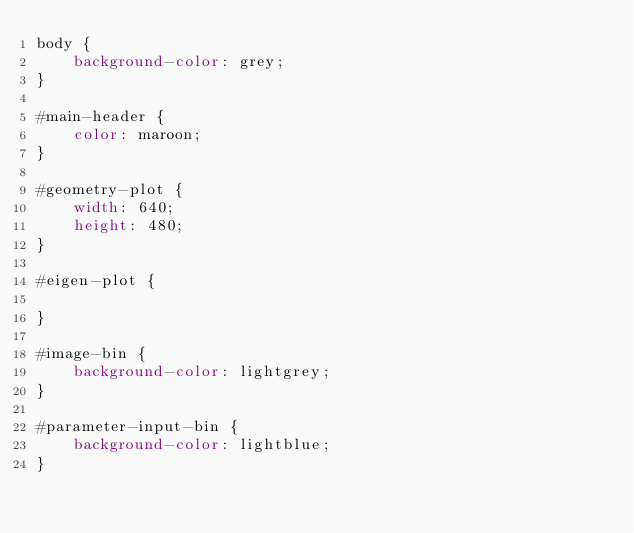<code> <loc_0><loc_0><loc_500><loc_500><_CSS_>body {
	background-color: grey;
}

#main-header {
	color: maroon;
}

#geometry-plot {
	width: 640;
	height: 480;
}

#eigen-plot {
	
}

#image-bin {
	background-color: lightgrey;
}

#parameter-input-bin {
	background-color: lightblue;
}</code> 